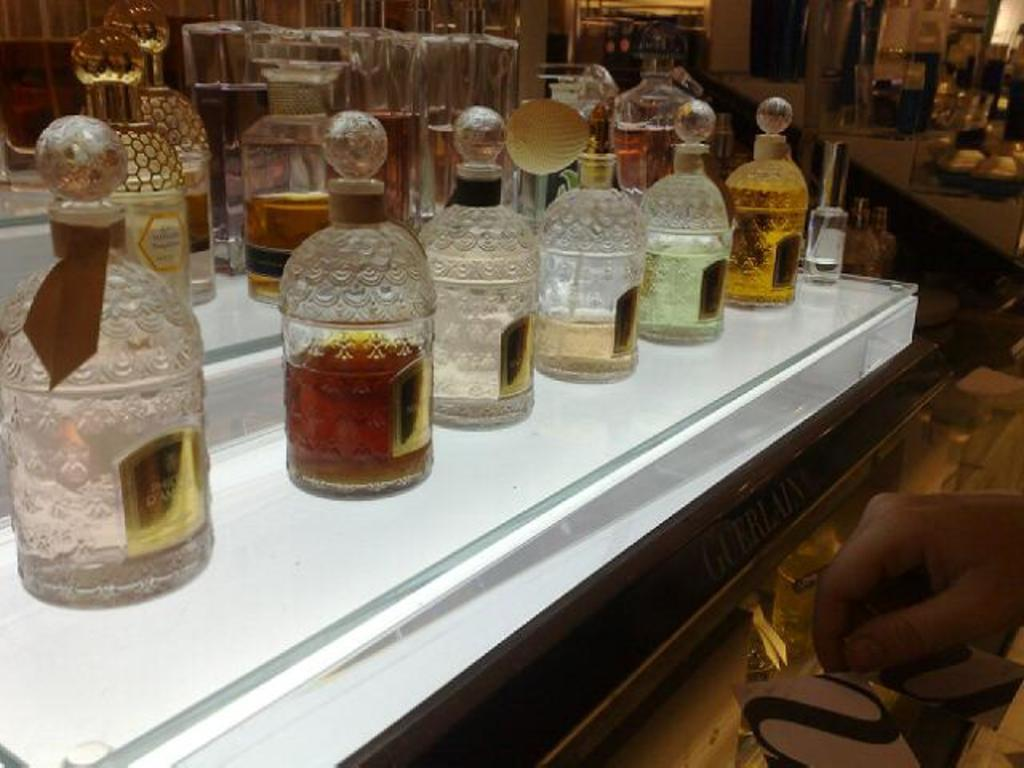What objects are on the table in the image? There is a group of bottles on a table in the image. Can you describe any body parts visible in the image? The right hand of a person is visible in the image. How many books are stacked on the person's neck in the image? There are no books visible in the image, and the person's neck is not mentioned. 